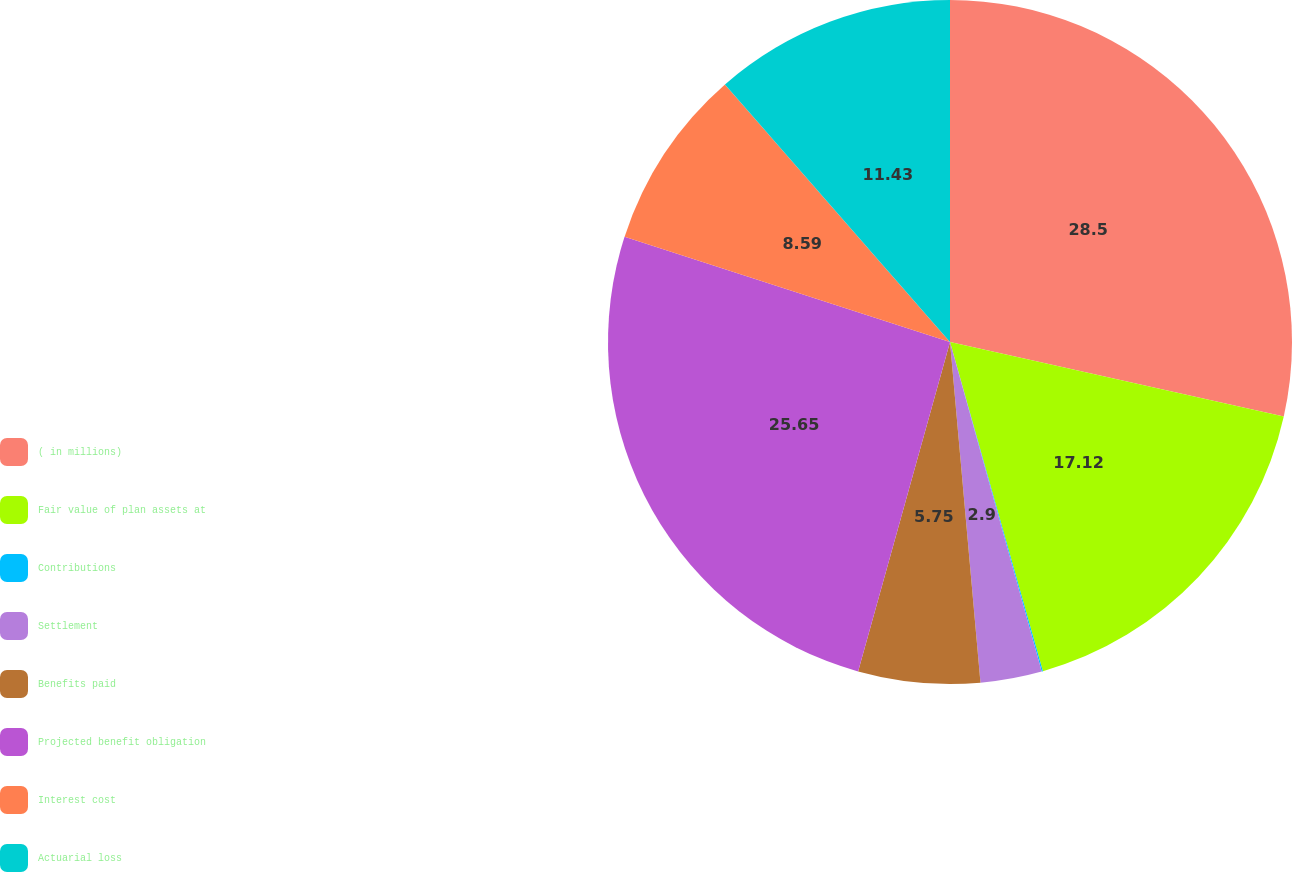Convert chart to OTSL. <chart><loc_0><loc_0><loc_500><loc_500><pie_chart><fcel>( in millions)<fcel>Fair value of plan assets at<fcel>Contributions<fcel>Settlement<fcel>Benefits paid<fcel>Projected benefit obligation<fcel>Interest cost<fcel>Actuarial loss<nl><fcel>28.5%<fcel>17.12%<fcel>0.06%<fcel>2.9%<fcel>5.75%<fcel>25.65%<fcel>8.59%<fcel>11.43%<nl></chart> 